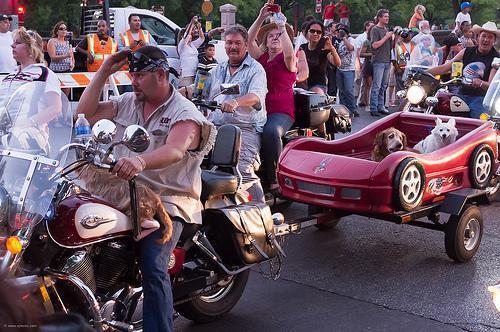How many dogs in the car?
Give a very brief answer. 2. 